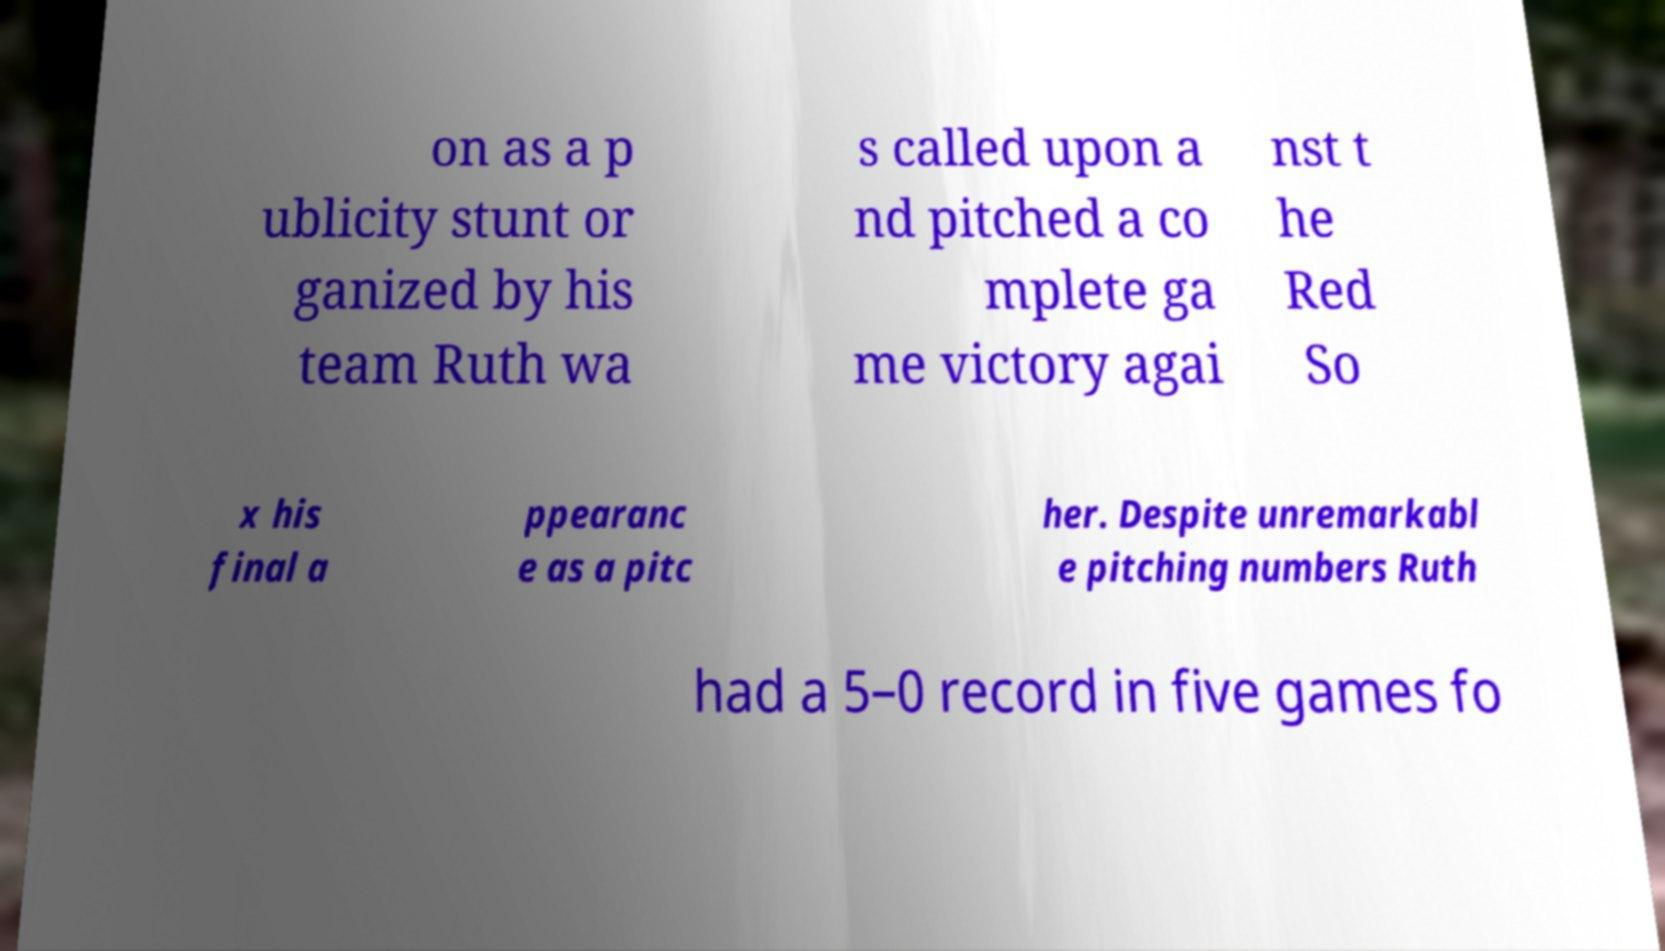What messages or text are displayed in this image? I need them in a readable, typed format. on as a p ublicity stunt or ganized by his team Ruth wa s called upon a nd pitched a co mplete ga me victory agai nst t he Red So x his final a ppearanc e as a pitc her. Despite unremarkabl e pitching numbers Ruth had a 5–0 record in five games fo 